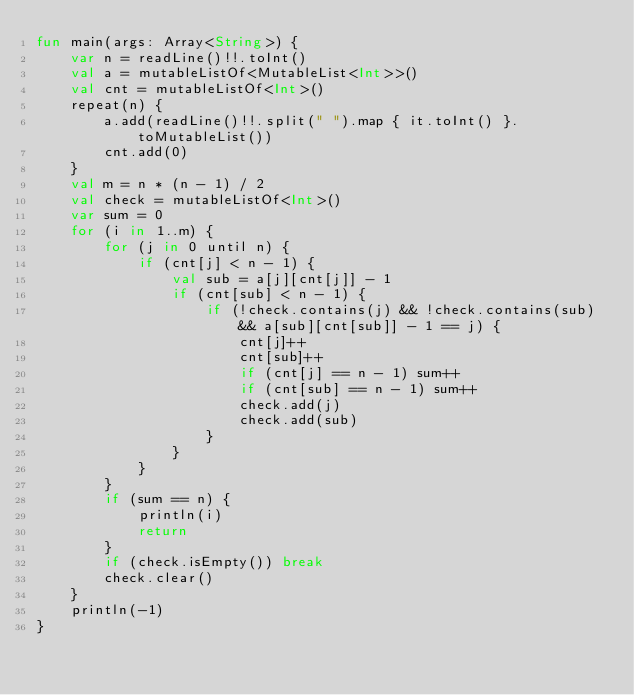Convert code to text. <code><loc_0><loc_0><loc_500><loc_500><_Kotlin_>fun main(args: Array<String>) {
    var n = readLine()!!.toInt()
    val a = mutableListOf<MutableList<Int>>()
    val cnt = mutableListOf<Int>()
    repeat(n) {
        a.add(readLine()!!.split(" ").map { it.toInt() }.toMutableList())
        cnt.add(0)
    }
    val m = n * (n - 1) / 2
    val check = mutableListOf<Int>()
    var sum = 0
    for (i in 1..m) {
        for (j in 0 until n) {
            if (cnt[j] < n - 1) {
                val sub = a[j][cnt[j]] - 1
                if (cnt[sub] < n - 1) {
                    if (!check.contains(j) && !check.contains(sub) && a[sub][cnt[sub]] - 1 == j) {
                        cnt[j]++
                        cnt[sub]++
                        if (cnt[j] == n - 1) sum++
                        if (cnt[sub] == n - 1) sum++
                        check.add(j)
                        check.add(sub)
                    }
                }
            }
        }
        if (sum == n) {
            println(i)
            return
        }
        if (check.isEmpty()) break
        check.clear()
    }
    println(-1)
}</code> 